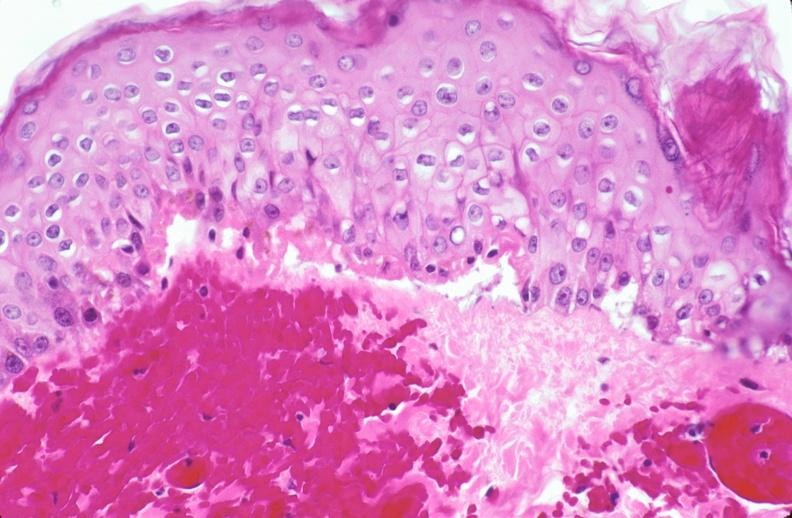where is this?
Answer the question using a single word or phrase. Skin 